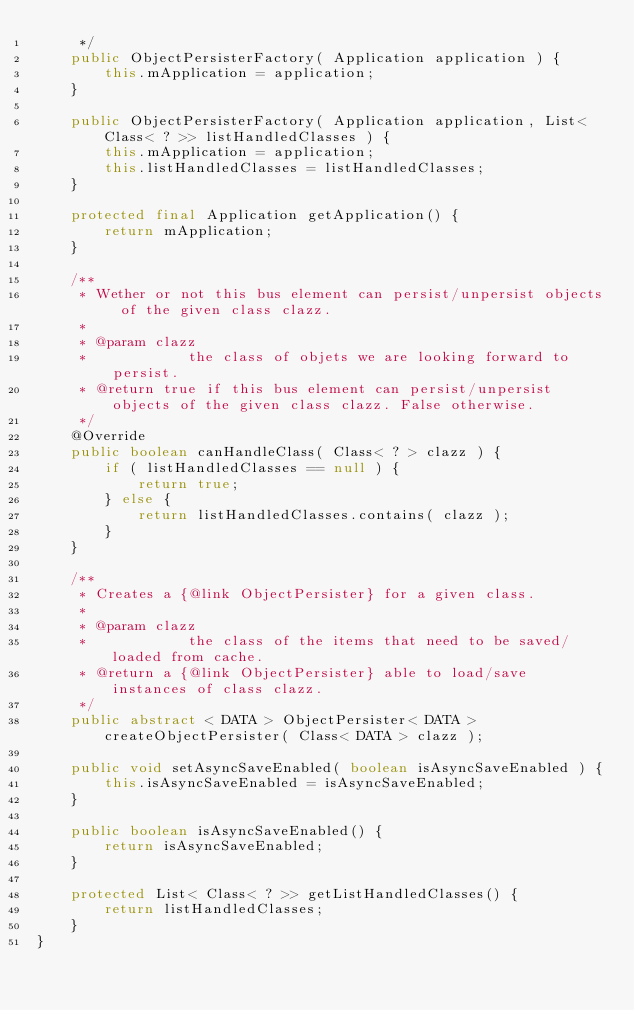Convert code to text. <code><loc_0><loc_0><loc_500><loc_500><_Java_>     */
    public ObjectPersisterFactory( Application application ) {
        this.mApplication = application;
    }

    public ObjectPersisterFactory( Application application, List< Class< ? >> listHandledClasses ) {
        this.mApplication = application;
        this.listHandledClasses = listHandledClasses;
    }

    protected final Application getApplication() {
        return mApplication;
    }

    /**
     * Wether or not this bus element can persist/unpersist objects of the given class clazz.
     * 
     * @param clazz
     *            the class of objets we are looking forward to persist.
     * @return true if this bus element can persist/unpersist objects of the given class clazz. False otherwise.
     */
    @Override
    public boolean canHandleClass( Class< ? > clazz ) {
        if ( listHandledClasses == null ) {
            return true;
        } else {
            return listHandledClasses.contains( clazz );
        }
    }

    /**
     * Creates a {@link ObjectPersister} for a given class.
     * 
     * @param clazz
     *            the class of the items that need to be saved/loaded from cache.
     * @return a {@link ObjectPersister} able to load/save instances of class clazz.
     */
    public abstract < DATA > ObjectPersister< DATA > createObjectPersister( Class< DATA > clazz );

    public void setAsyncSaveEnabled( boolean isAsyncSaveEnabled ) {
        this.isAsyncSaveEnabled = isAsyncSaveEnabled;
    }

    public boolean isAsyncSaveEnabled() {
        return isAsyncSaveEnabled;
    }

    protected List< Class< ? >> getListHandledClasses() {
        return listHandledClasses;
    }
}</code> 